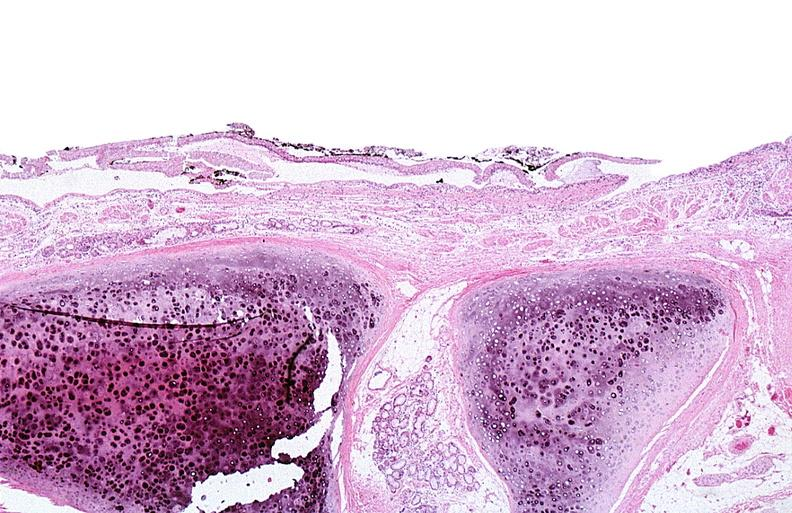does this image show thermal burned skin?
Answer the question using a single word or phrase. Yes 